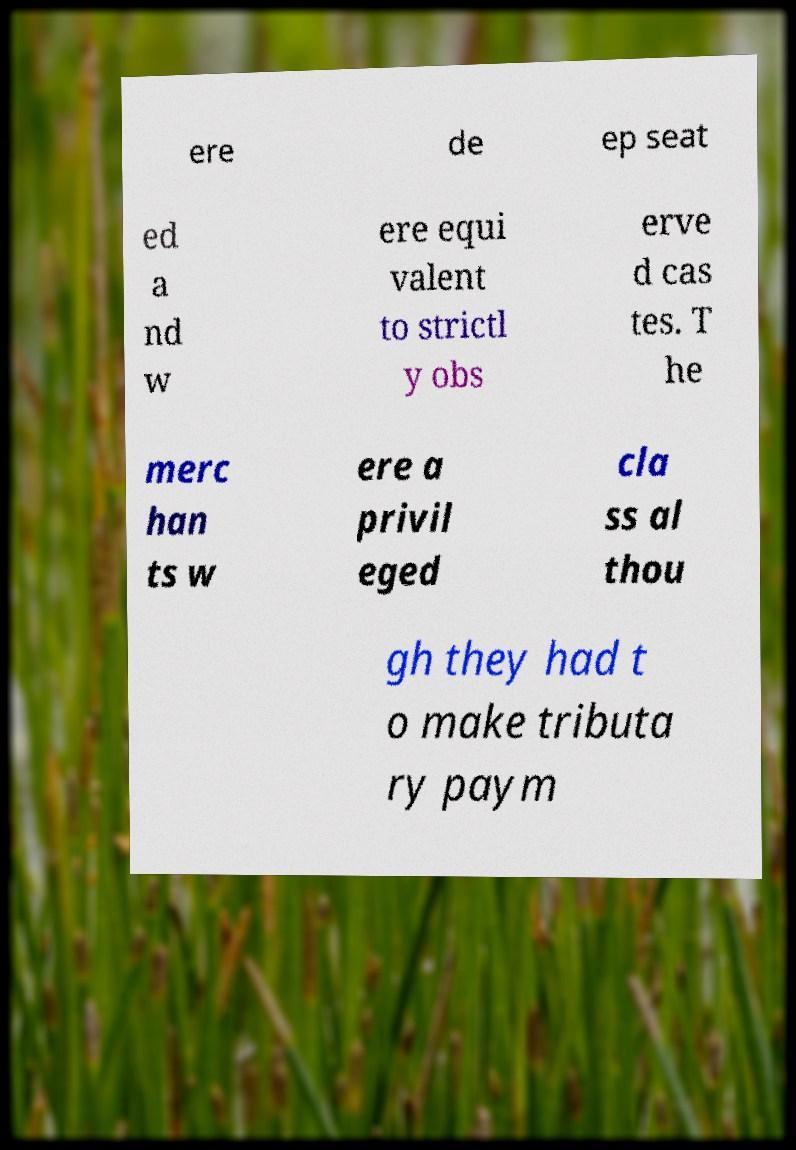Could you assist in decoding the text presented in this image and type it out clearly? ere de ep seat ed a nd w ere equi valent to strictl y obs erve d cas tes. T he merc han ts w ere a privil eged cla ss al thou gh they had t o make tributa ry paym 